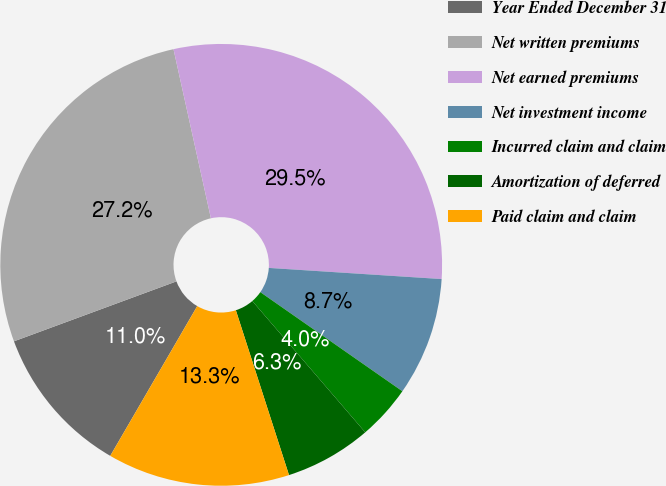Convert chart to OTSL. <chart><loc_0><loc_0><loc_500><loc_500><pie_chart><fcel>Year Ended December 31<fcel>Net written premiums<fcel>Net earned premiums<fcel>Net investment income<fcel>Incurred claim and claim<fcel>Amortization of deferred<fcel>Paid claim and claim<nl><fcel>11.0%<fcel>27.16%<fcel>29.49%<fcel>8.67%<fcel>4.0%<fcel>6.34%<fcel>13.34%<nl></chart> 